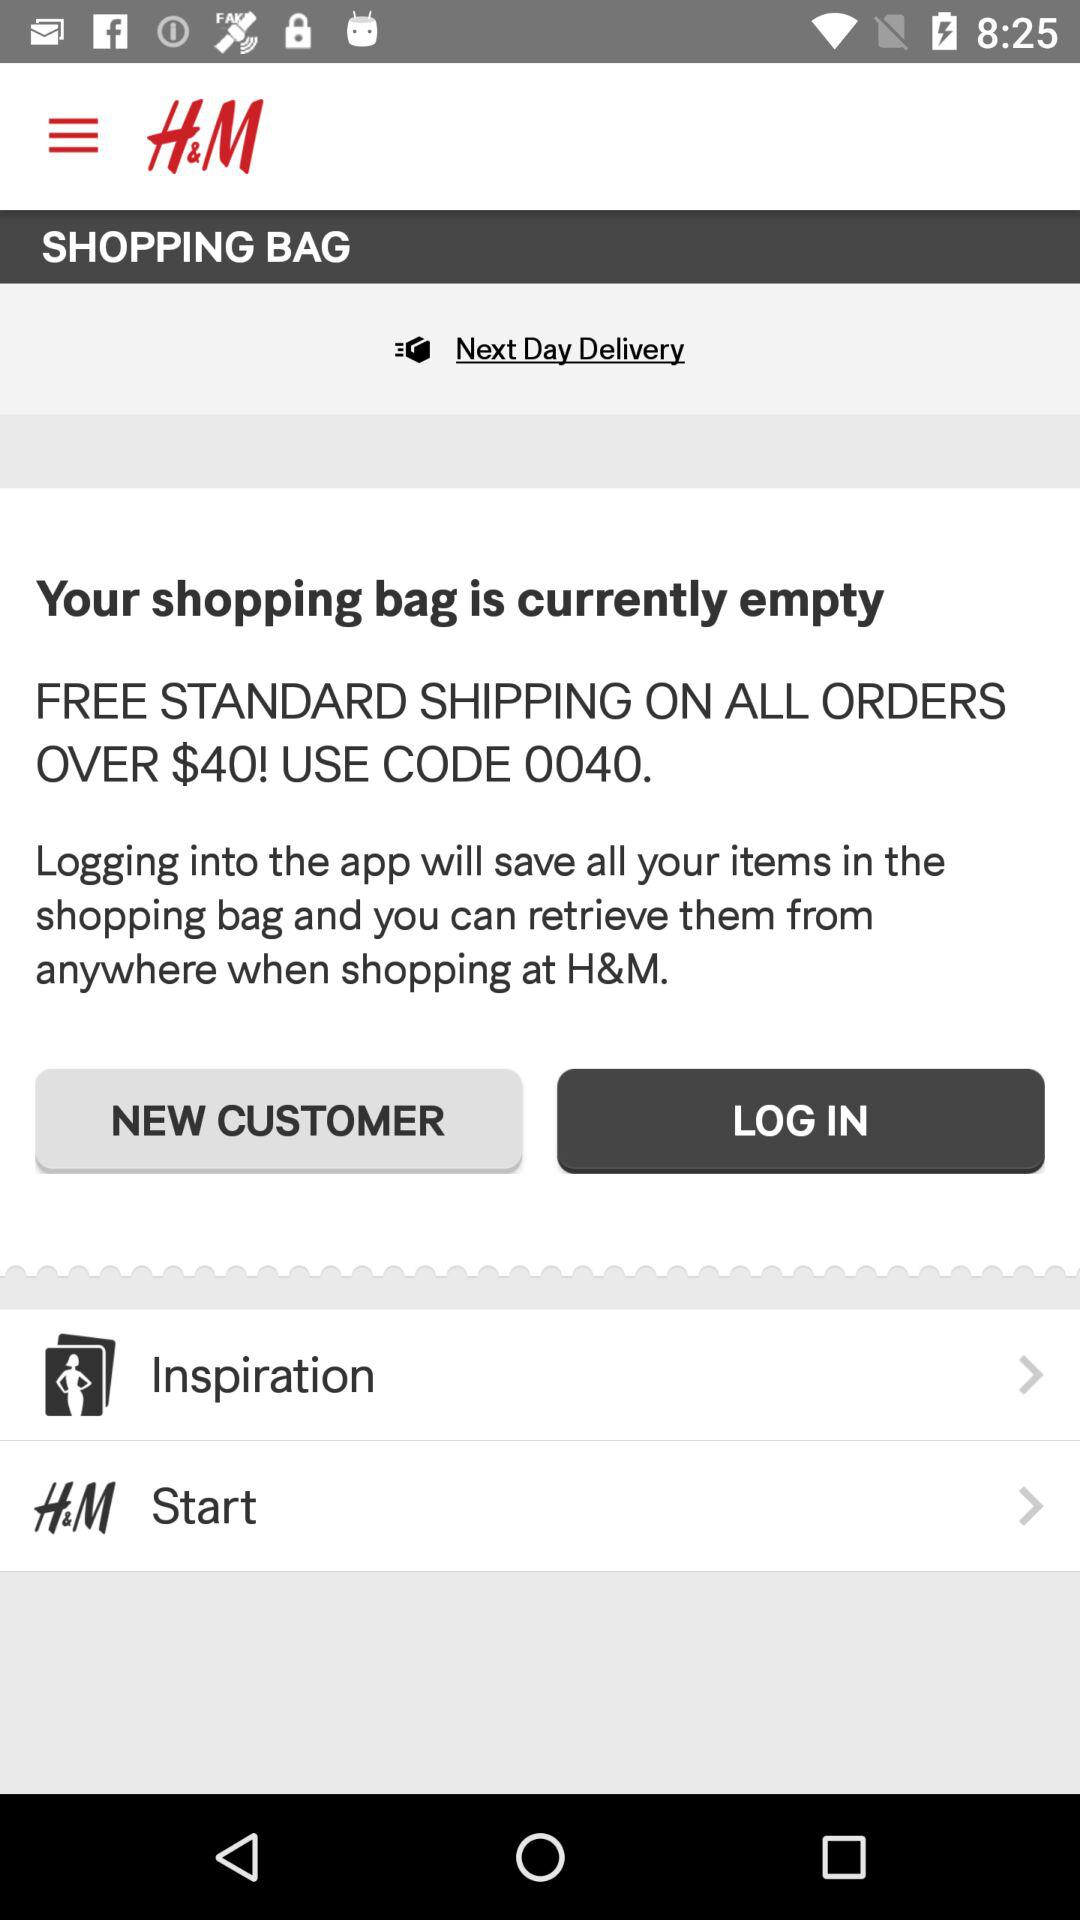What is the code that can be used for free shipping? The code is "0040". 